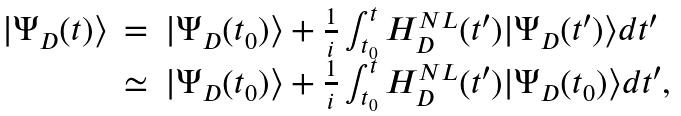<formula> <loc_0><loc_0><loc_500><loc_500>\begin{array} { r c l } | \Psi _ { D } ( t ) \rangle & = & | \Psi _ { D } ( t _ { 0 } ) \rangle + \frac { 1 } { i } \int _ { t _ { 0 } } ^ { t } H ^ { N L } _ { D } ( t ^ { \prime } ) | \Psi _ { D } ( t ^ { \prime } ) \rangle d t ^ { \prime } \\ & \simeq & | \Psi _ { D } ( t _ { 0 } ) \rangle + \frac { 1 } { i } \int _ { t _ { 0 } } ^ { t } H ^ { N L } _ { D } ( t ^ { \prime } ) | \Psi _ { D } ( t _ { 0 } ) \rangle d t ^ { \prime } , \end{array}</formula> 